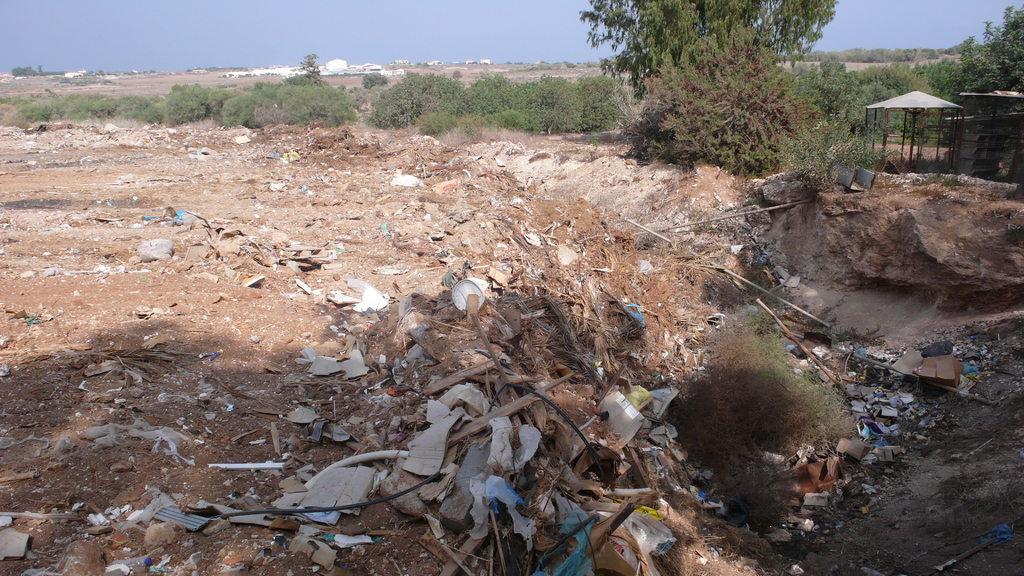How would you summarize this image in a sentence or two? In this picture we can see few plants, trees and sheds, in the background we can see few buildings. 